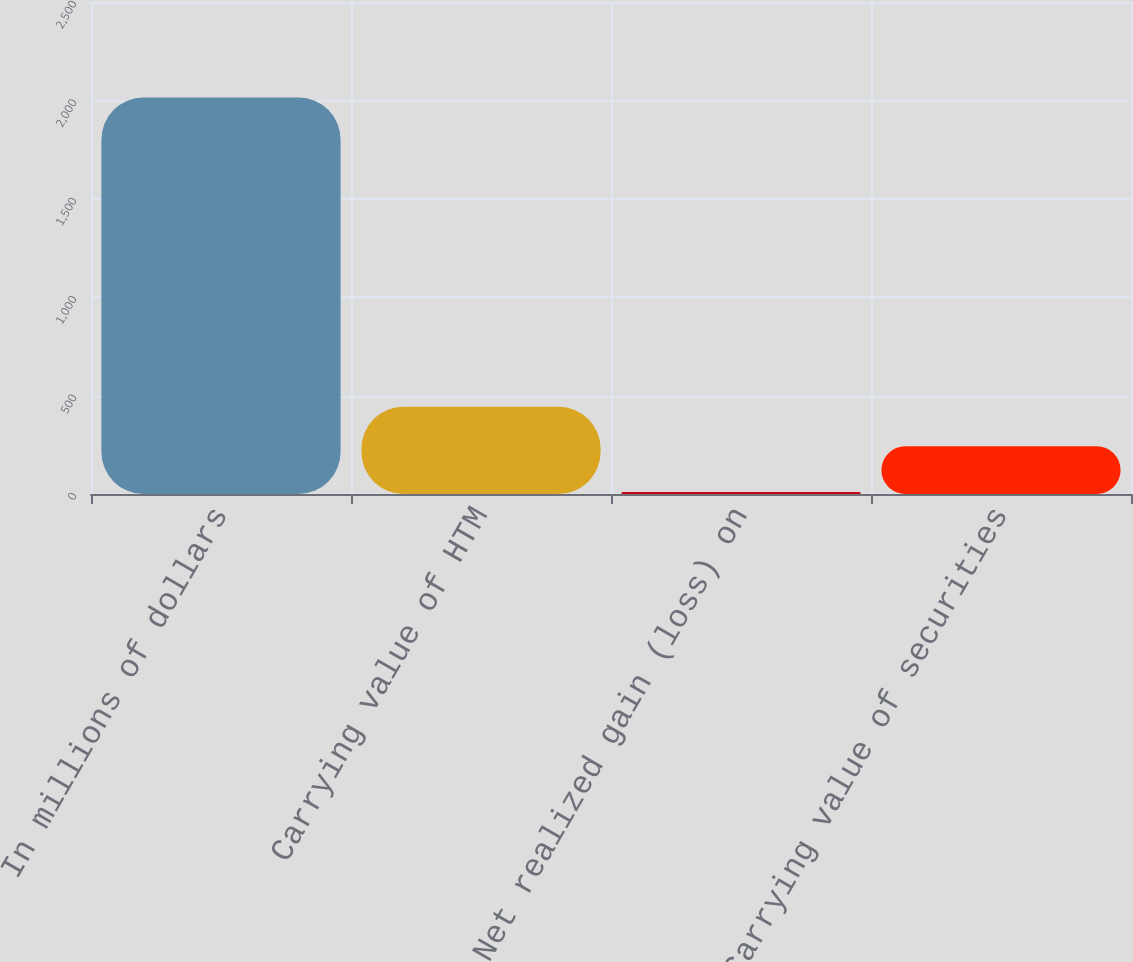Convert chart. <chart><loc_0><loc_0><loc_500><loc_500><bar_chart><fcel>In millions of dollars<fcel>Carrying value of HTM<fcel>Net realized gain (loss) on<fcel>Carrying value of securities<nl><fcel>2015<fcel>443.5<fcel>10<fcel>243<nl></chart> 